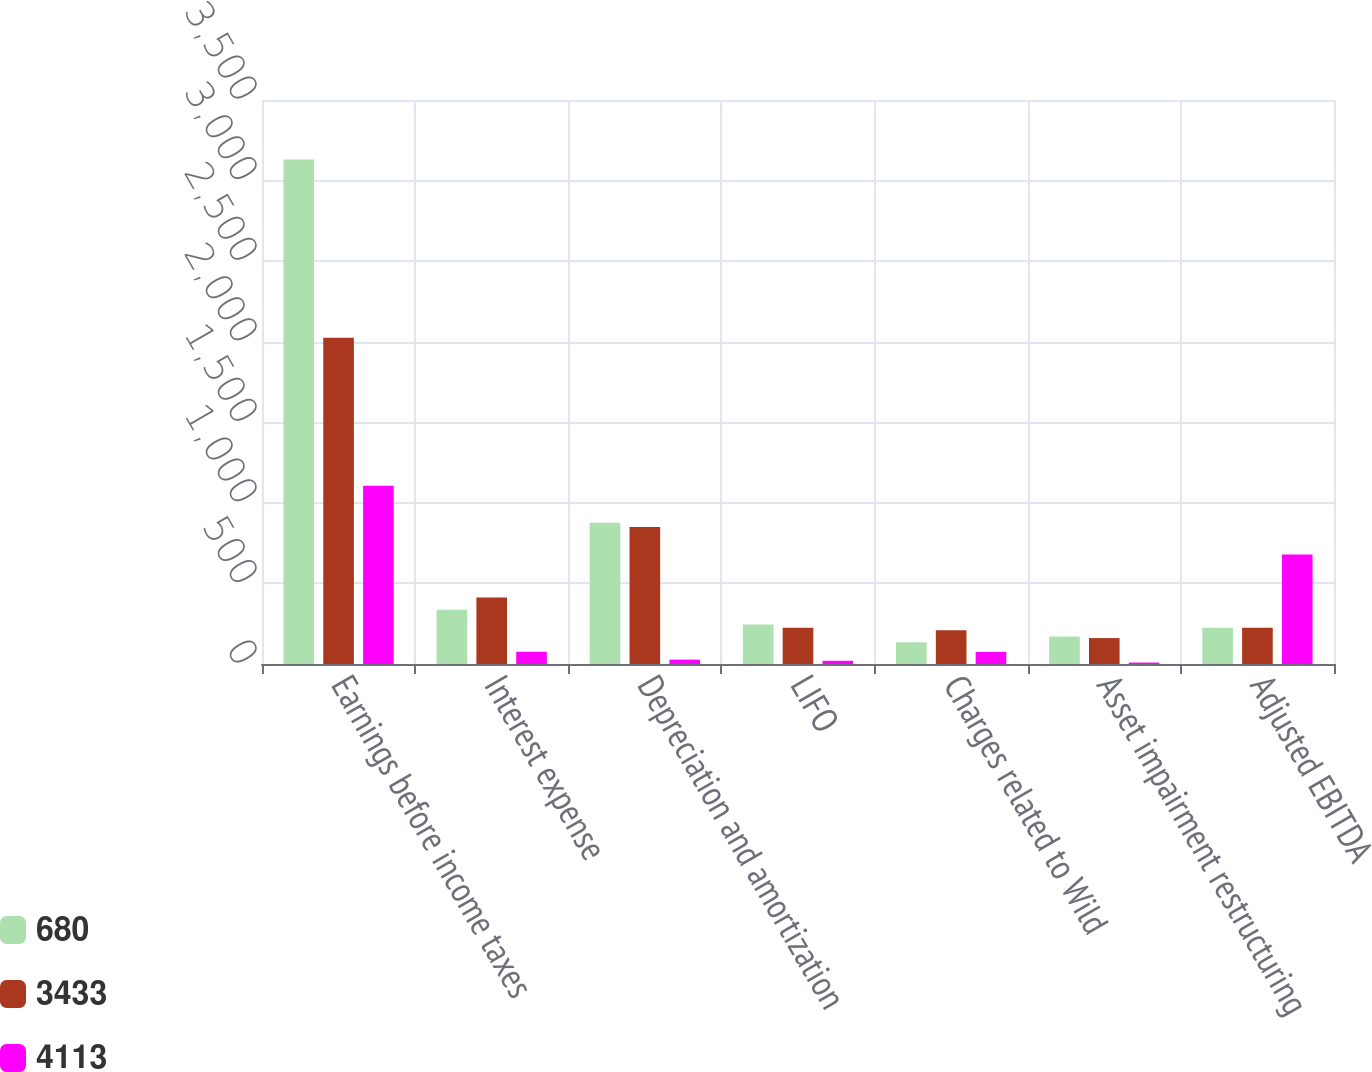<chart> <loc_0><loc_0><loc_500><loc_500><stacked_bar_chart><ecel><fcel>Earnings before income taxes<fcel>Interest expense<fcel>Depreciation and amortization<fcel>LIFO<fcel>Charges related to Wild<fcel>Asset impairment restructuring<fcel>Adjusted EBITDA<nl><fcel>680<fcel>3130<fcel>337<fcel>877<fcel>245<fcel>135<fcel>170<fcel>225<nl><fcel>3433<fcel>2024<fcel>413<fcel>850<fcel>225<fcel>210<fcel>161<fcel>225<nl><fcel>4113<fcel>1106<fcel>76<fcel>27<fcel>20<fcel>75<fcel>9<fcel>680<nl></chart> 